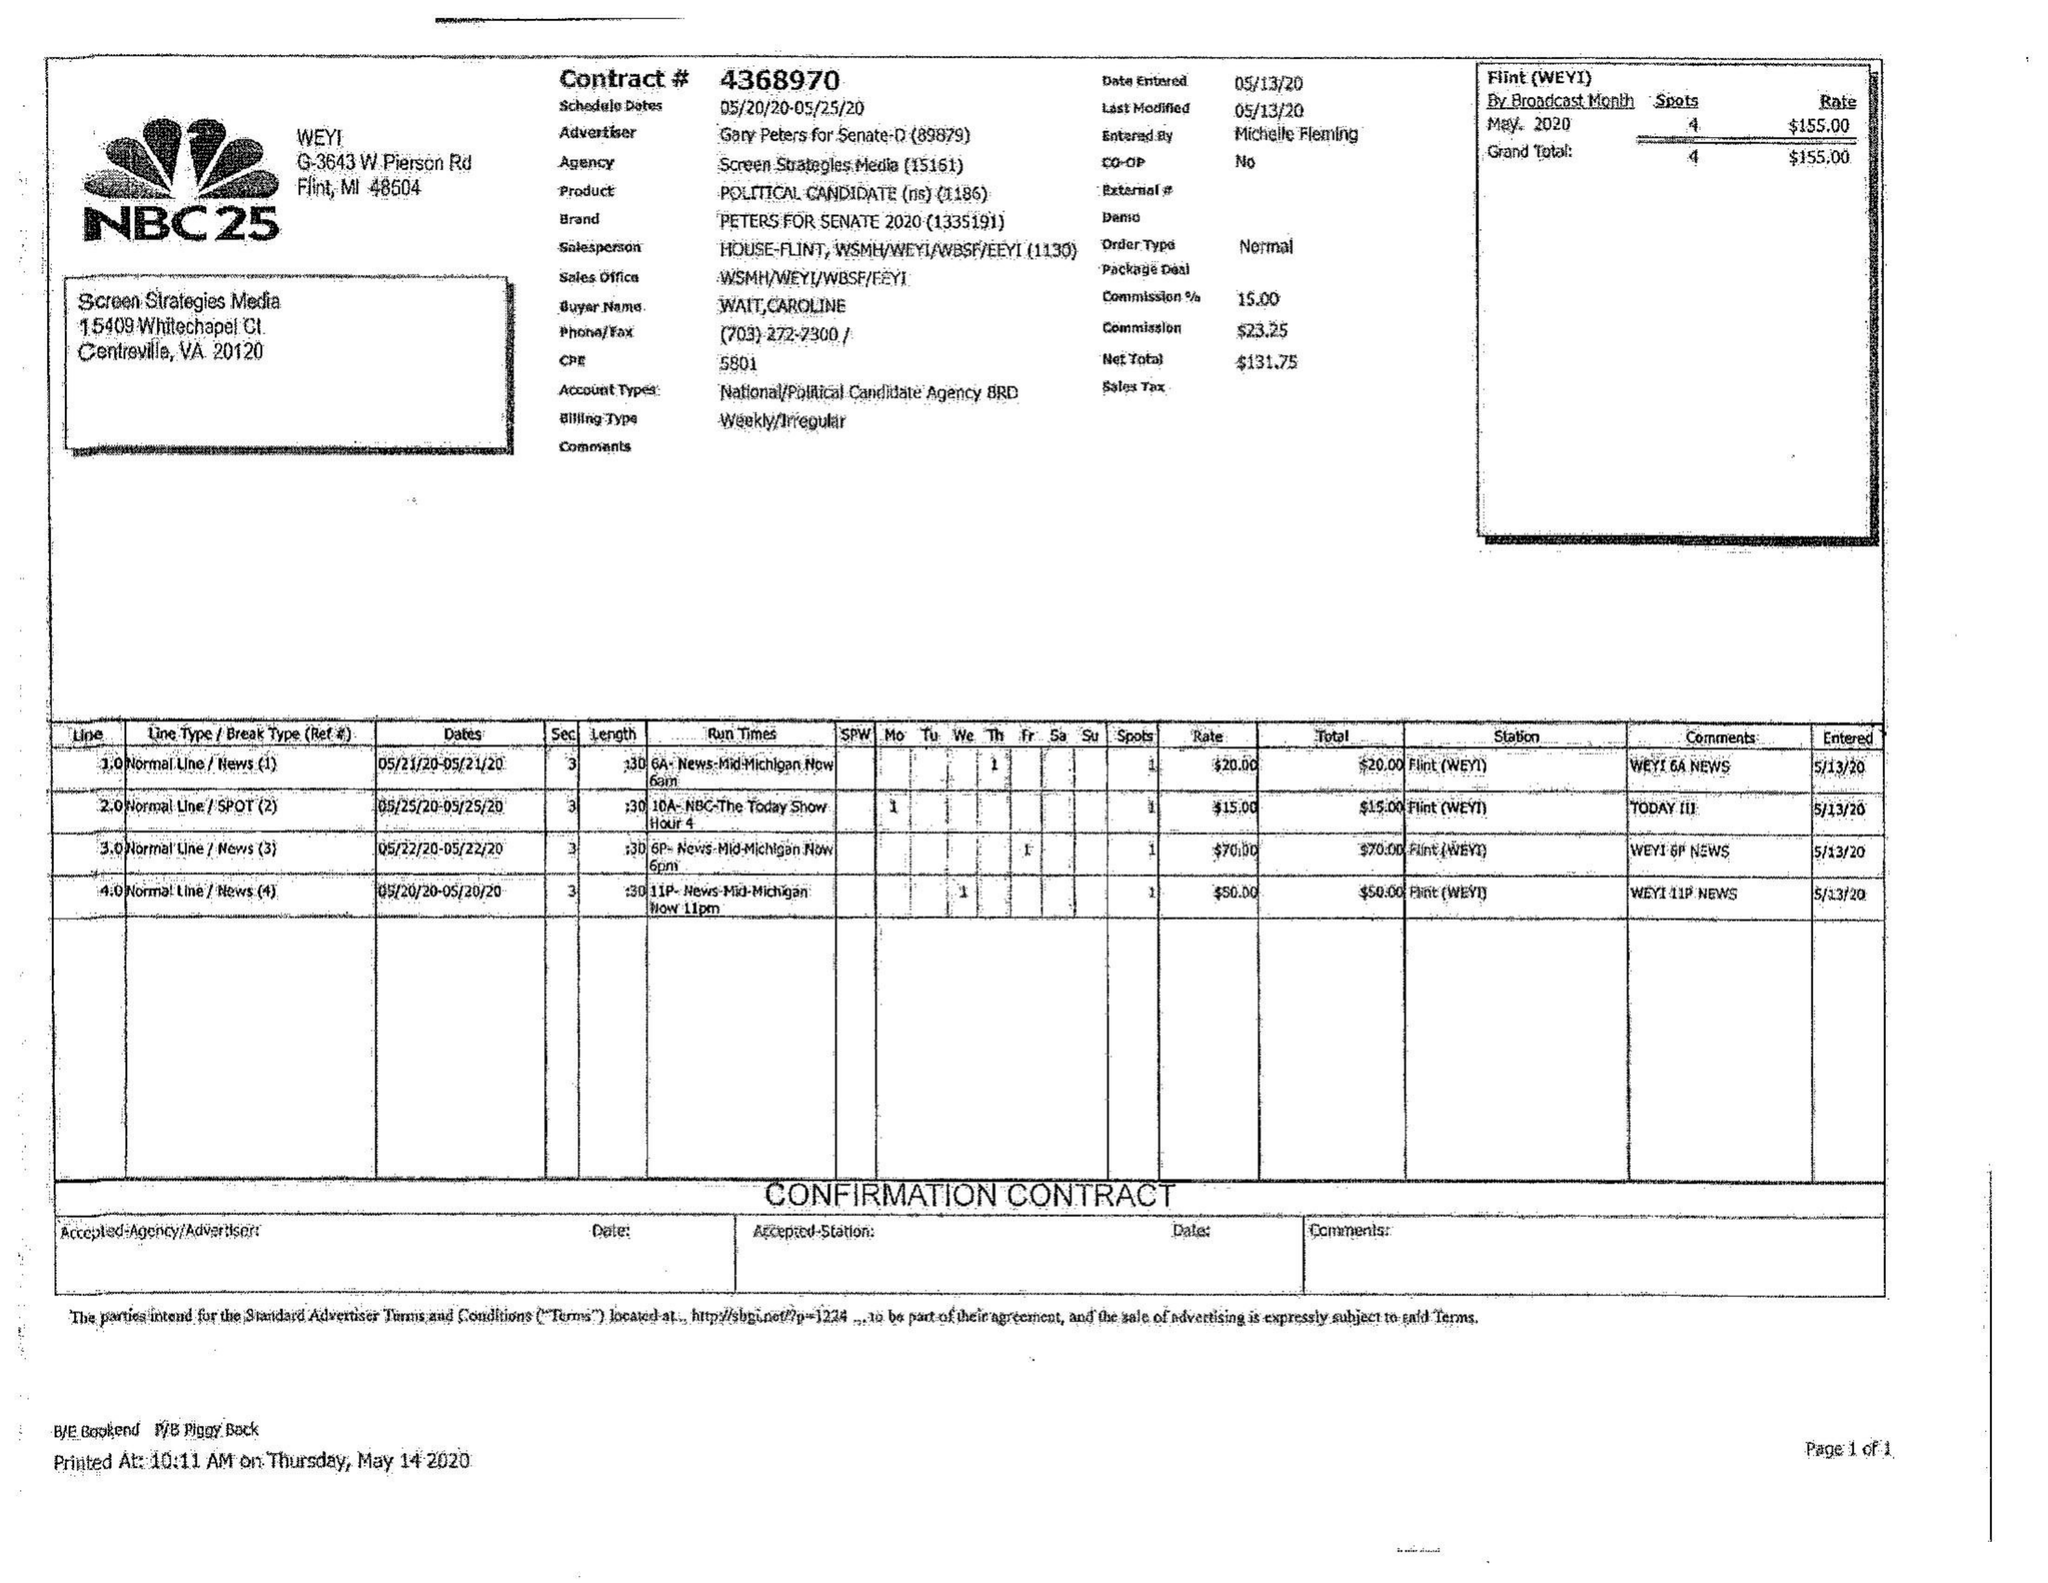What is the value for the flight_to?
Answer the question using a single word or phrase. 05/25/20 